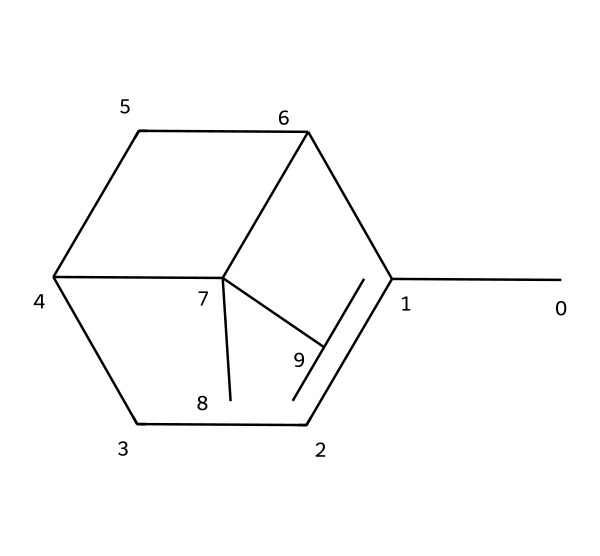What is the name of this chemical? The structure provided corresponds to a compound known as pinene, a common terpene.
Answer: pinene How many carbon atoms are present in pinene? By analyzing the structure, it is clear that there are 10 carbon atoms arranged in various configurations.
Answer: 10 What type of bonds predominantly exist in this chemical structure? The structure shows mainly single bonds (sigma bonds) and also includes double bonds. The representation of the double bonds can be inferred from the arrangement.
Answer: single and double Is pinene a saturated or unsaturated compound? Since pinene contains a double bond, it qualifies as an unsaturated compound, as saturation requires only single bonds.
Answer: unsaturated What functional group is present in pinene? The structural representation does not show any specific functional groups like alcohol or carbonyl; it mainly shows a hydrocarbon framework typical of terpenes.
Answer: hydrocarbon How does the presence of carbon-bonding affect the aroma of pinene? Pinene's structure allows for the volatilities and interactions with receptors in the nose, helping it to contribute to a fresh, pine-like aroma due to the arrangement of carbon and hydrogen.
Answer: fresh aroma What class of chemicals does pinene belong to? Pinene is classified as a terpene, which are organic compounds produced by a variety of plants, particularly conifers.
Answer: terpene 